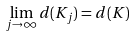<formula> <loc_0><loc_0><loc_500><loc_500>\lim _ { j \to \infty } d ( K _ { j } ) = d ( K )</formula> 